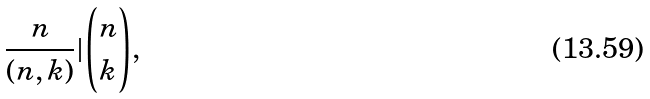<formula> <loc_0><loc_0><loc_500><loc_500>\frac { n } { ( n , k ) } | \binom { n } { k } ,</formula> 